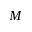Convert formula to latex. <formula><loc_0><loc_0><loc_500><loc_500>M</formula> 